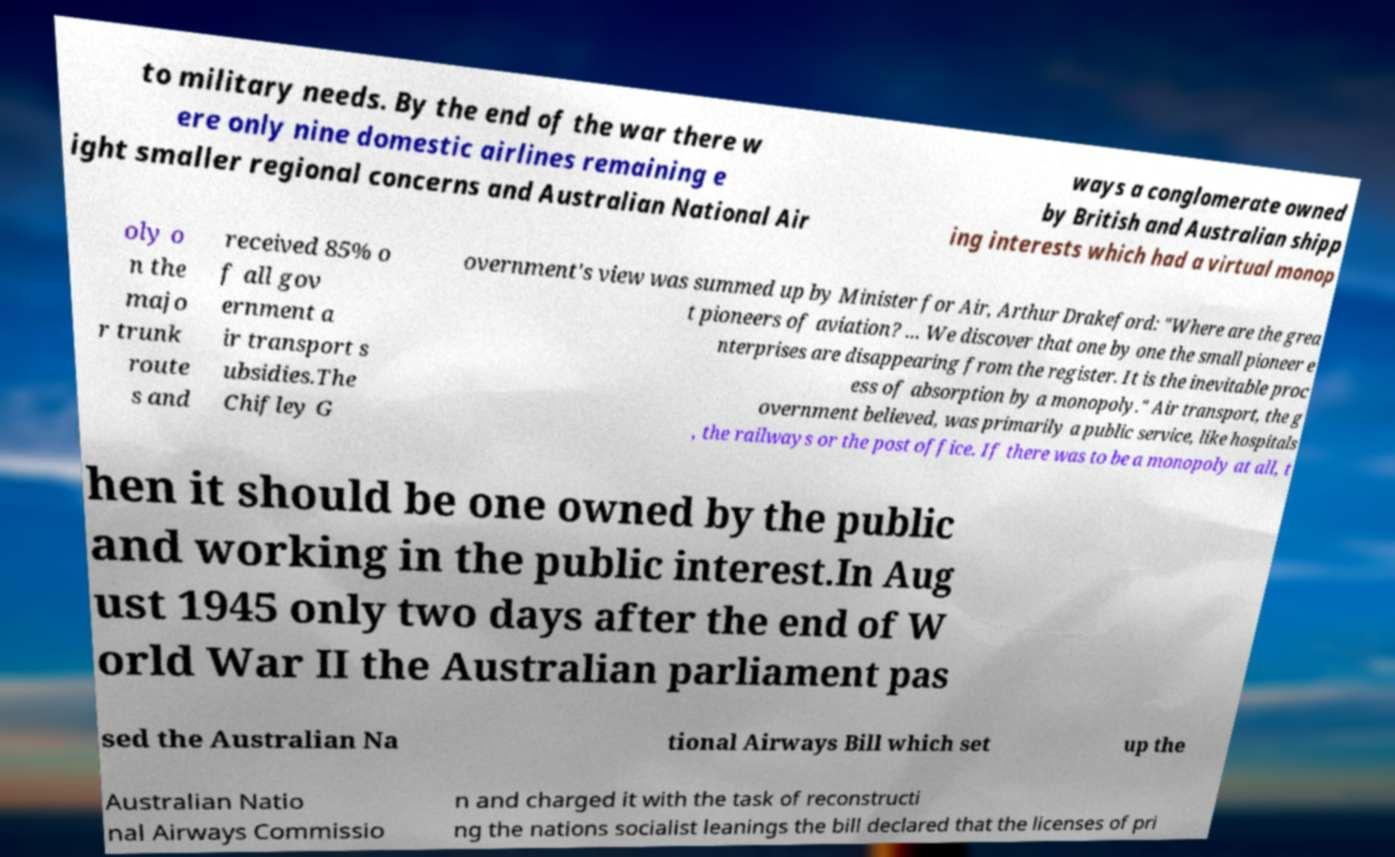Please identify and transcribe the text found in this image. to military needs. By the end of the war there w ere only nine domestic airlines remaining e ight smaller regional concerns and Australian National Air ways a conglomerate owned by British and Australian shipp ing interests which had a virtual monop oly o n the majo r trunk route s and received 85% o f all gov ernment a ir transport s ubsidies.The Chifley G overnment's view was summed up by Minister for Air, Arthur Drakeford: "Where are the grea t pioneers of aviation? ... We discover that one by one the small pioneer e nterprises are disappearing from the register. It is the inevitable proc ess of absorption by a monopoly." Air transport, the g overnment believed, was primarily a public service, like hospitals , the railways or the post office. If there was to be a monopoly at all, t hen it should be one owned by the public and working in the public interest.In Aug ust 1945 only two days after the end of W orld War II the Australian parliament pas sed the Australian Na tional Airways Bill which set up the Australian Natio nal Airways Commissio n and charged it with the task of reconstructi ng the nations socialist leanings the bill declared that the licenses of pri 